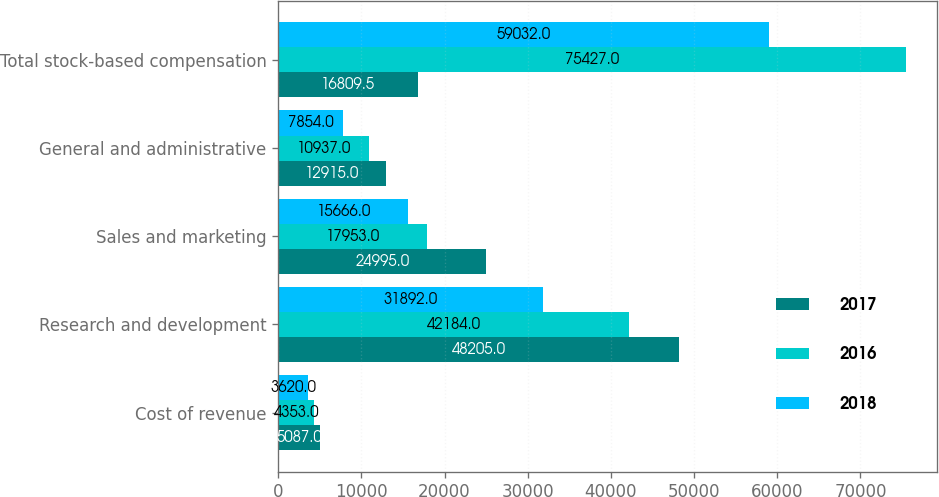Convert chart. <chart><loc_0><loc_0><loc_500><loc_500><stacked_bar_chart><ecel><fcel>Cost of revenue<fcel>Research and development<fcel>Sales and marketing<fcel>General and administrative<fcel>Total stock-based compensation<nl><fcel>2017<fcel>5087<fcel>48205<fcel>24995<fcel>12915<fcel>16809.5<nl><fcel>2016<fcel>4353<fcel>42184<fcel>17953<fcel>10937<fcel>75427<nl><fcel>2018<fcel>3620<fcel>31892<fcel>15666<fcel>7854<fcel>59032<nl></chart> 